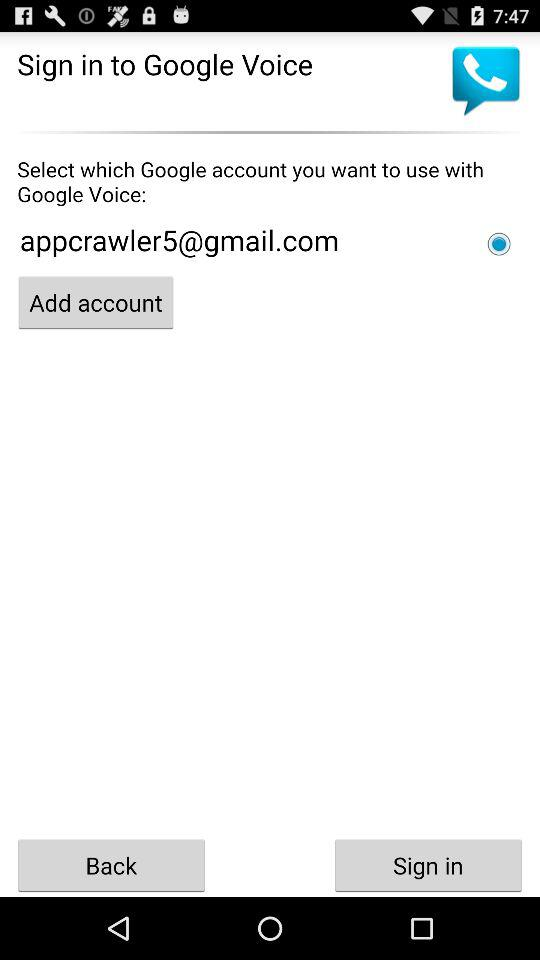What is the selected email address? The selected email address is appcrawler5@gmail.com. 